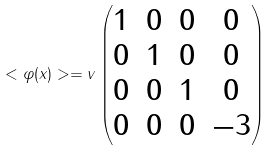Convert formula to latex. <formula><loc_0><loc_0><loc_500><loc_500>< \varphi ( x ) > = v \begin{pmatrix} 1 & 0 & 0 & 0 \\ 0 & 1 & 0 & 0 \\ 0 & 0 & 1 & 0 \\ 0 & 0 & 0 & - 3 \end{pmatrix}</formula> 